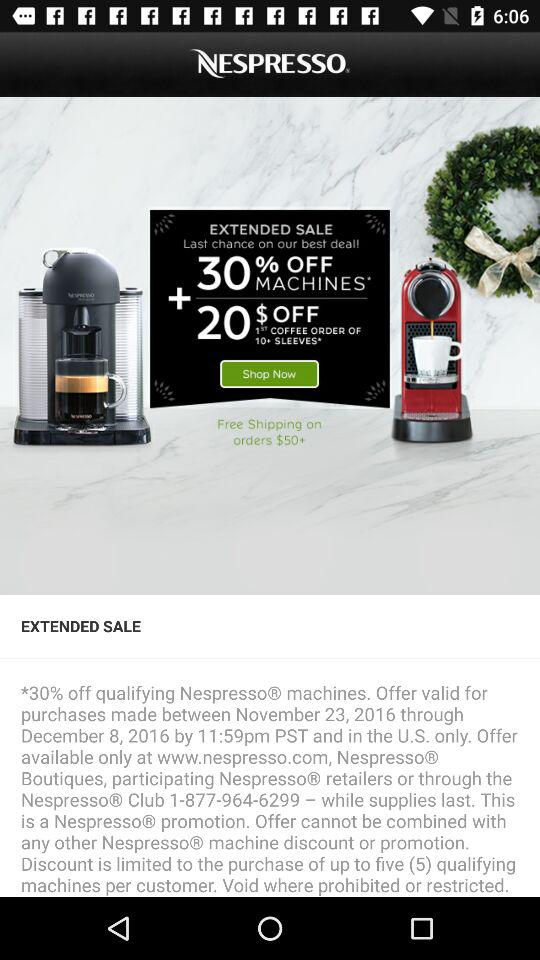How much is off on the first coffee order of more than ten sleeves? There is $20 off on the first coffee order of more than ten sleeves. 